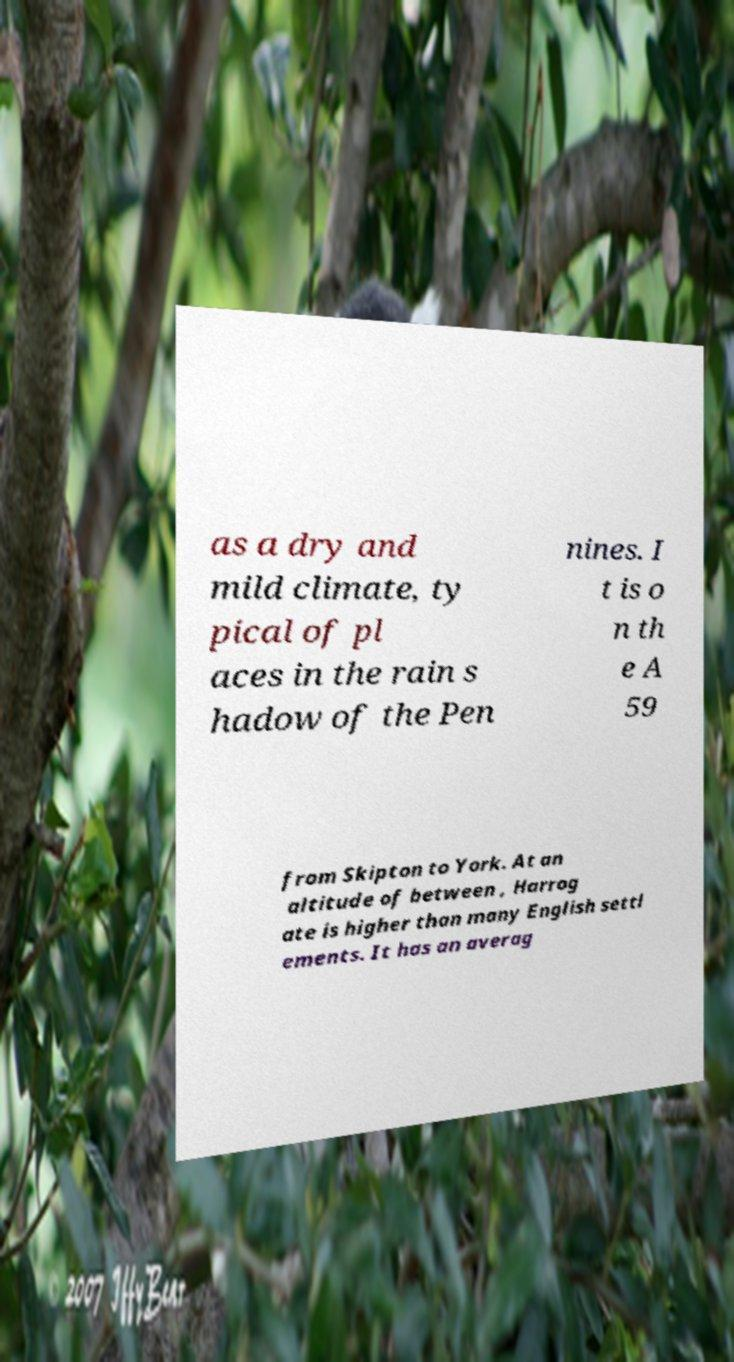There's text embedded in this image that I need extracted. Can you transcribe it verbatim? as a dry and mild climate, ty pical of pl aces in the rain s hadow of the Pen nines. I t is o n th e A 59 from Skipton to York. At an altitude of between , Harrog ate is higher than many English settl ements. It has an averag 